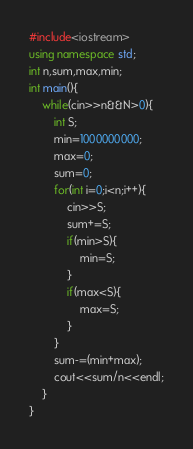<code> <loc_0><loc_0><loc_500><loc_500><_C++_>#include<iostream>
using namespace std;
int n,sum,max,min;
int main(){
	while(cin>>n&&N>0){
		int S;
		min=1000000000;
		max=0;
		sum=0;
		for(int i=0;i<n;i++){
			cin>>S;
			sum+=S;
			if(min>S){
				min=S;
			}
			if(max<S){
				max=S;
			}
		}
		sum-=(min+max);
		cout<<sum/n<<endl;
	}
}</code> 